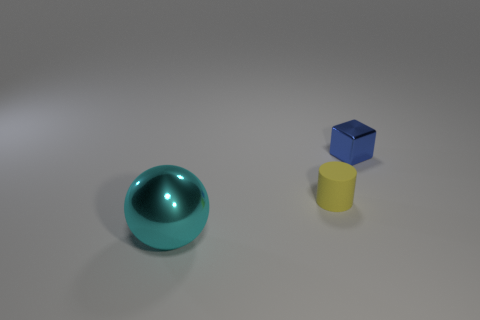Add 1 cyan metallic balls. How many objects exist? 4 Subtract all spheres. How many objects are left? 2 Subtract all tiny blue objects. Subtract all yellow matte objects. How many objects are left? 1 Add 2 yellow rubber cylinders. How many yellow rubber cylinders are left? 3 Add 1 blue shiny objects. How many blue shiny objects exist? 2 Subtract 1 blue cubes. How many objects are left? 2 